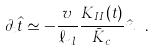Convert formula to latex. <formula><loc_0><loc_0><loc_500><loc_500>\partial _ { t } \hat { t } \simeq - \frac { v } { \ell _ { n l } } \frac { K _ { I I } ( t ) } { \bar { K } _ { c } } \hat { n } \ .</formula> 